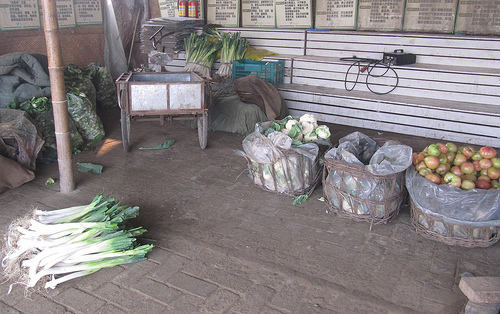<image>
Is the vegetables under the sink? No. The vegetables is not positioned under the sink. The vertical relationship between these objects is different. 